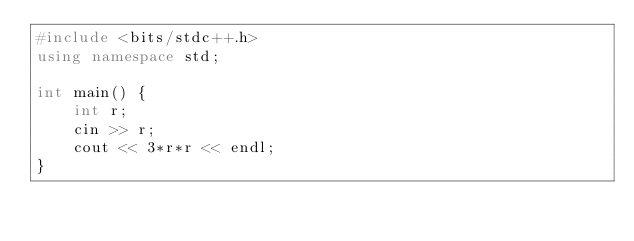<code> <loc_0><loc_0><loc_500><loc_500><_C++_>#include <bits/stdc++.h>
using namespace std;

int main() {
    int r;
    cin >> r;
    cout << 3*r*r << endl;
}
</code> 